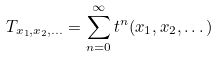Convert formula to latex. <formula><loc_0><loc_0><loc_500><loc_500>T _ { x _ { 1 } , x _ { 2 } , \dots } = \sum ^ { \infty } _ { n = 0 } t ^ { n } ( x _ { 1 } , x _ { 2 } , \dots )</formula> 